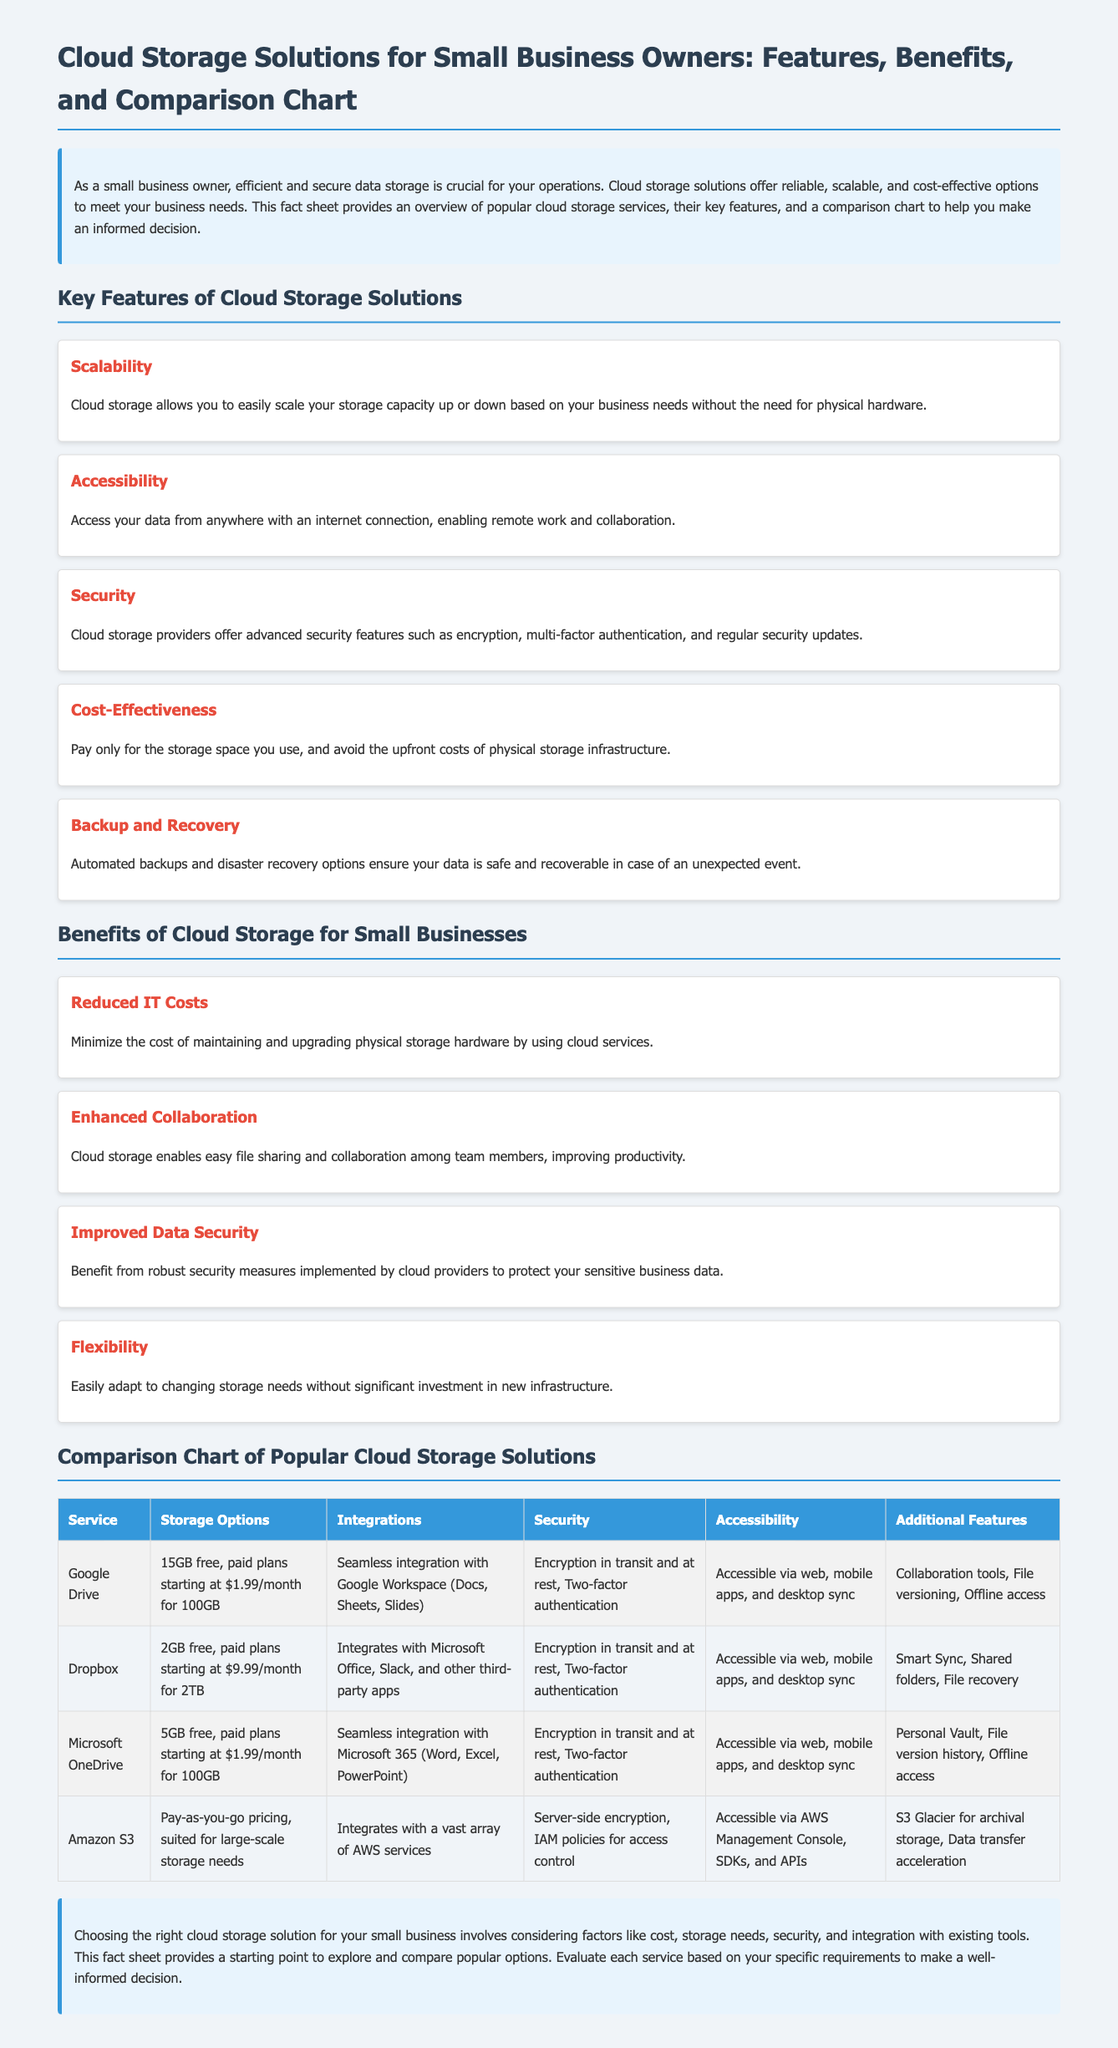What are the key features of cloud storage solutions? The document lists five key features: Scalability, Accessibility, Security, Cost-Effectiveness, and Backup and Recovery.
Answer: Scalability, Accessibility, Security, Cost-Effectiveness, Backup and Recovery How much free storage does Dropbox offer? The document states that Dropbox offers 2GB of free storage.
Answer: 2GB What type of integration does Google Drive provide? Google Drive offers seamless integration with Google Workspace (Docs, Sheets, Slides).
Answer: Google Workspace (Docs, Sheets, Slides) Which service has the lowest monthly paid plan? The paid plans for Google Drive and Microsoft OneDrive both start at $1.99/month for 100GB.
Answer: $1.99/month What is one benefit of using cloud storage for small businesses? One benefit mentioned is reduced IT costs, allowing businesses to minimize the cost of maintaining and upgrading physical storage.
Answer: Reduced IT Costs How does cloud storage improve collaboration in small businesses? The document explains that cloud storage enables easy file sharing and collaboration among team members, improving productivity.
Answer: Enhanced Collaboration What security measures do cloud storage providers typically implement? The document mentions encryption, multi-factor authentication, and regular security updates as typical security measures.
Answer: Encryption, multi-factor authentication, regular security updates What is the accessibility of Microsoft OneDrive? Microsoft OneDrive is accessible via web, mobile apps, and desktop sync.
Answer: Web, mobile apps, desktop sync What is the purpose of the comparison chart in the document? The comparison chart helps readers evaluate different cloud storage solutions based on features like storage options, integrations, security, and accessibility.
Answer: Evaluate different cloud storage solutions 